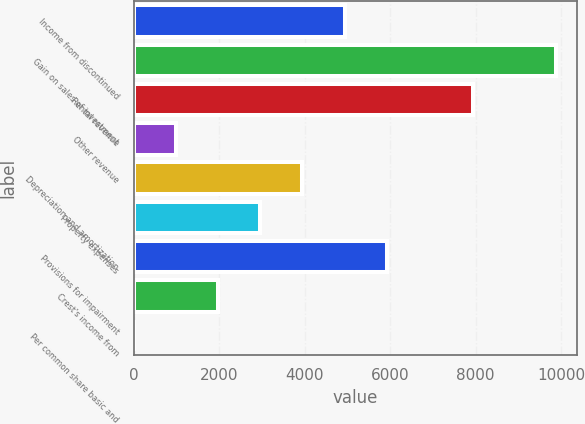Convert chart. <chart><loc_0><loc_0><loc_500><loc_500><bar_chart><fcel>Income from discontinued<fcel>Gain on sales of investment<fcel>Rental revenue<fcel>Other revenue<fcel>Depreciation and amortization<fcel>Property expenses<fcel>Provisions for impairment<fcel>Crest's income from<fcel>Per common share basic and<nl><fcel>4936.55<fcel>9873<fcel>7938<fcel>987.39<fcel>3949.26<fcel>2961.97<fcel>5923.84<fcel>1974.68<fcel>0.1<nl></chart> 